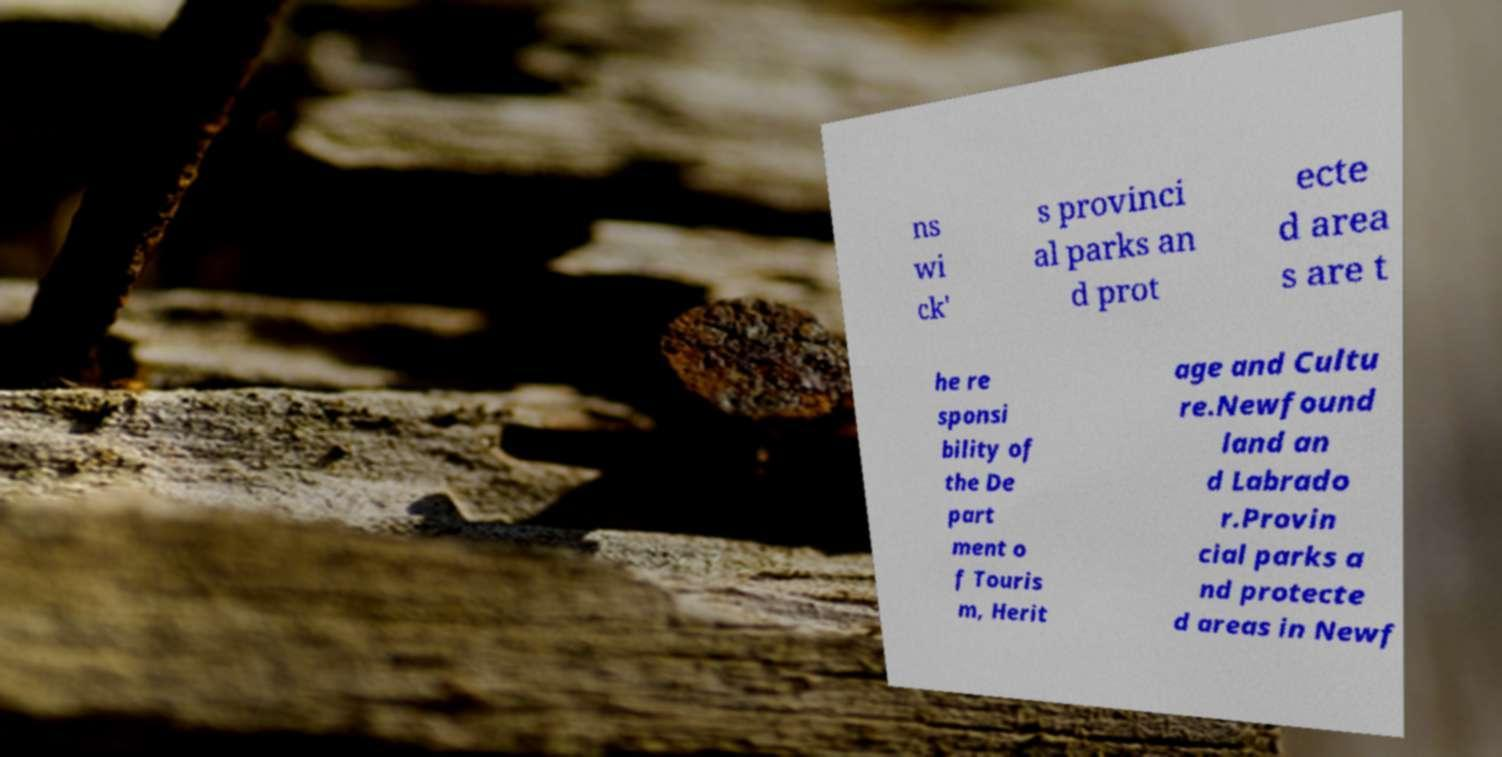Can you read and provide the text displayed in the image?This photo seems to have some interesting text. Can you extract and type it out for me? ns wi ck' s provinci al parks an d prot ecte d area s are t he re sponsi bility of the De part ment o f Touris m, Herit age and Cultu re.Newfound land an d Labrado r.Provin cial parks a nd protecte d areas in Newf 